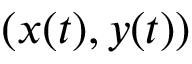<formula> <loc_0><loc_0><loc_500><loc_500>( x ( t ) , y ( t ) )</formula> 